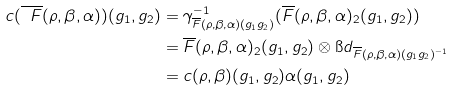Convert formula to latex. <formula><loc_0><loc_0><loc_500><loc_500>c ( \overline { \ F } ( \rho , \beta , \alpha ) ) ( g _ { 1 } , g _ { 2 } ) & = \gamma ^ { - 1 } _ { \overline { F } ( \rho , \beta , \alpha ) ( g _ { 1 } g _ { 2 } ) } ( \overline { F } ( \rho , \beta , \alpha ) _ { 2 } ( g _ { 1 } , g _ { 2 } ) ) \\ & = \overline { F } ( \rho , \beta , \alpha ) _ { 2 } ( g _ { 1 } , g _ { 2 } ) \otimes { \i d } _ { \overline { F } ( \rho , \beta , \alpha ) ( g _ { 1 } g _ { 2 } ) ^ { - 1 } } \\ & = c ( \rho , \beta ) ( g _ { 1 } , g _ { 2 } ) \alpha ( g _ { 1 } , g _ { 2 } )</formula> 